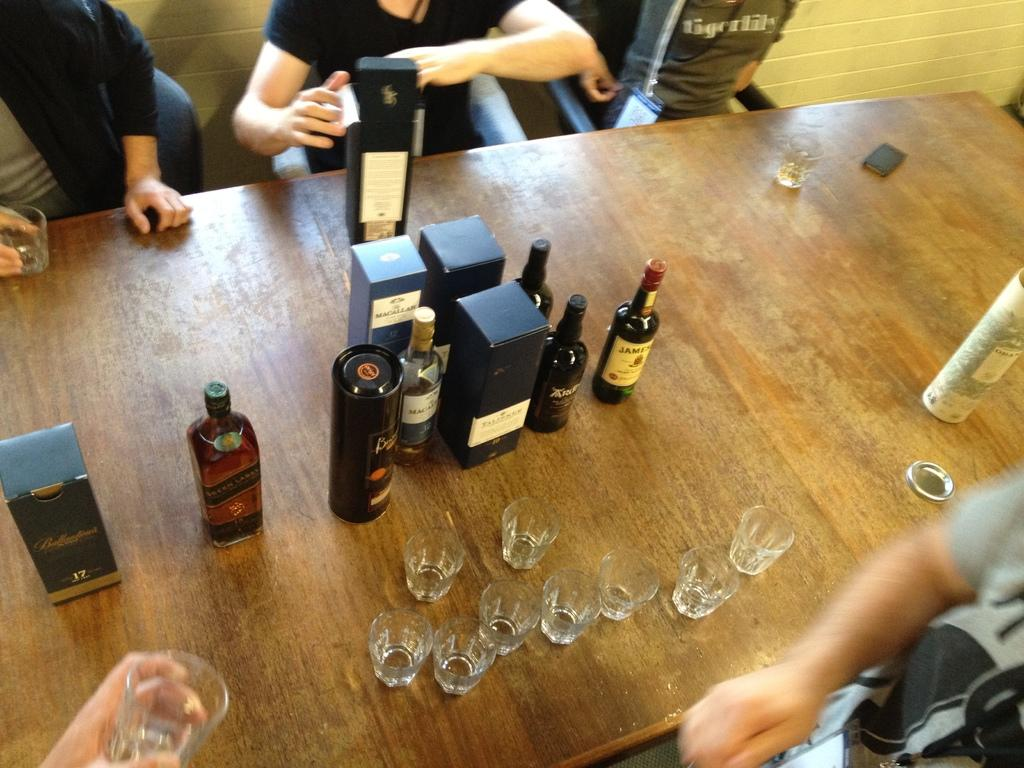What type of furniture is present in the image? There is a table in the image. What objects are on the table? There are bottles and glasses on the table. Are there any people in the image? Yes, there are persons in the image. What is one person doing with a glass? One person is holding a glass with their hand. What can be seen in the background of the image? There is a wall in the image. What type of roof can be seen in the image? There is no roof visible in the image; only a table, bottles, glasses, persons, and a wall are present. What is the condition of the person's knee in the image? There is no information about a person's knee in the image, as the focus is on the table, bottles, glasses, and wall. 